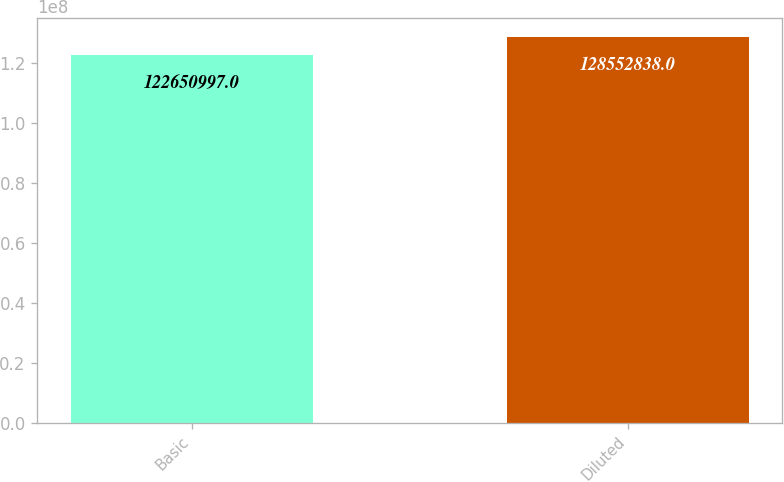Convert chart to OTSL. <chart><loc_0><loc_0><loc_500><loc_500><bar_chart><fcel>Basic<fcel>Diluted<nl><fcel>1.22651e+08<fcel>1.28553e+08<nl></chart> 